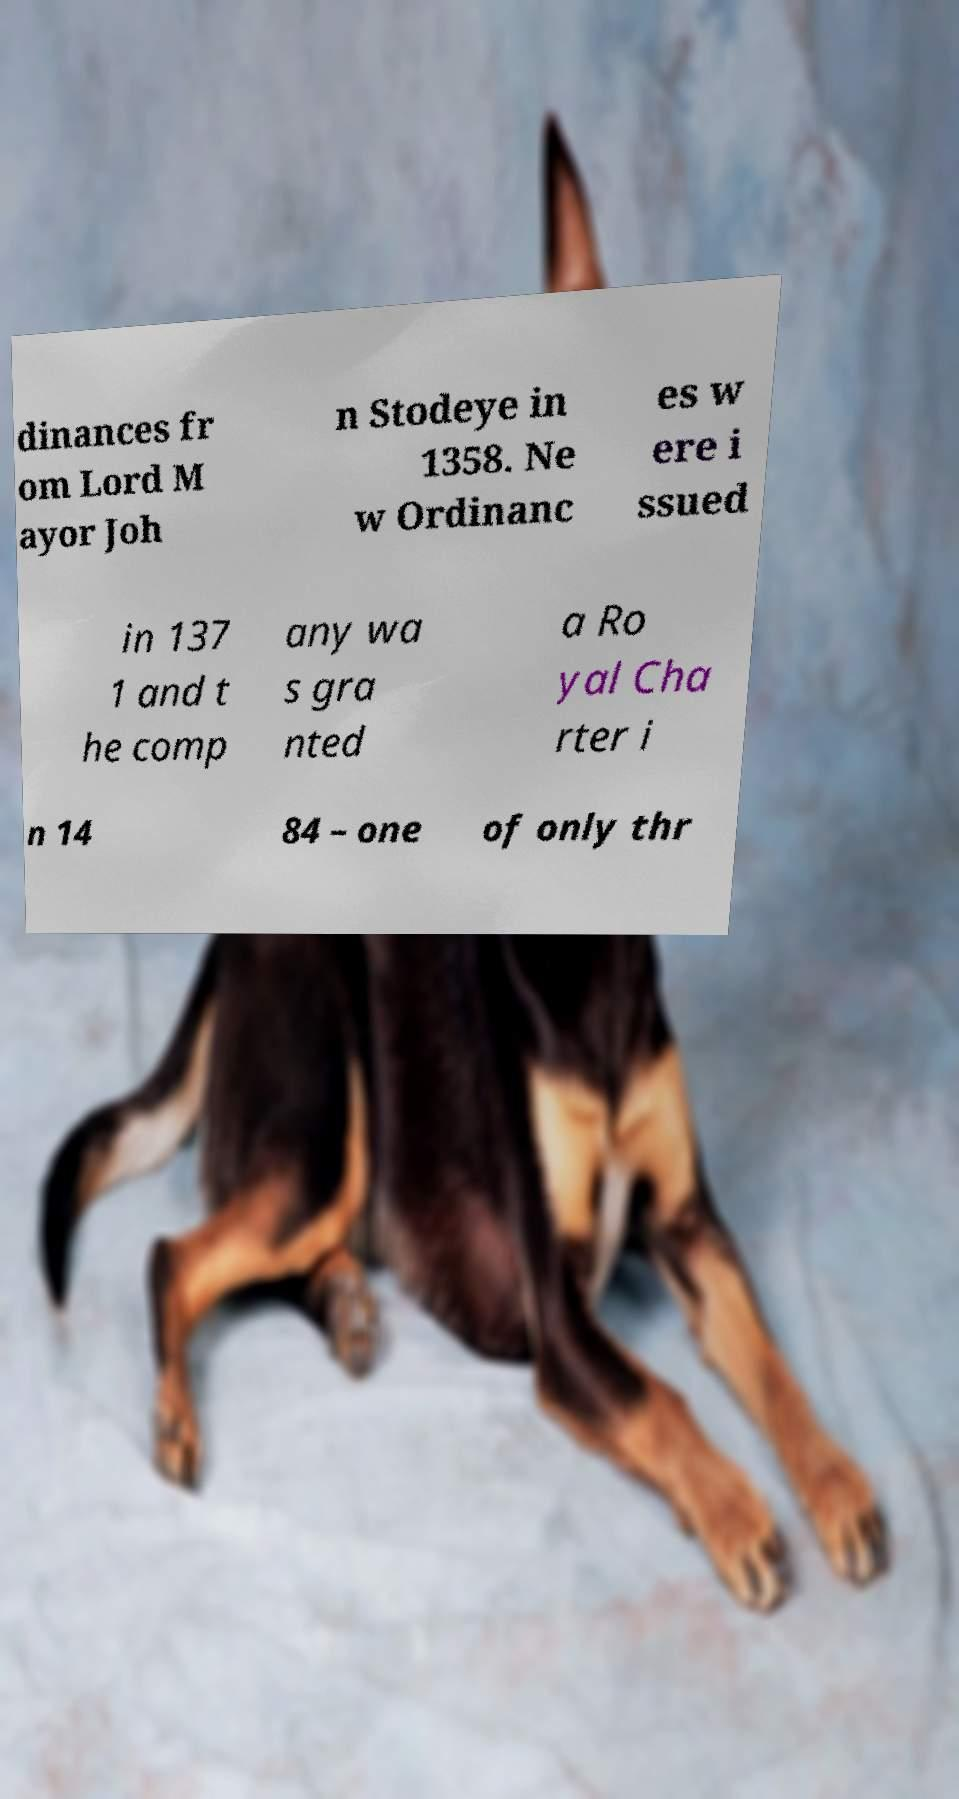For documentation purposes, I need the text within this image transcribed. Could you provide that? dinances fr om Lord M ayor Joh n Stodeye in 1358. Ne w Ordinanc es w ere i ssued in 137 1 and t he comp any wa s gra nted a Ro yal Cha rter i n 14 84 – one of only thr 